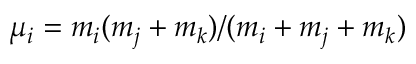<formula> <loc_0><loc_0><loc_500><loc_500>\mu _ { i } = { m _ { i } ( m _ { j } + m _ { k } ) } / ( { m _ { i } + m _ { j } + m _ { k } } )</formula> 